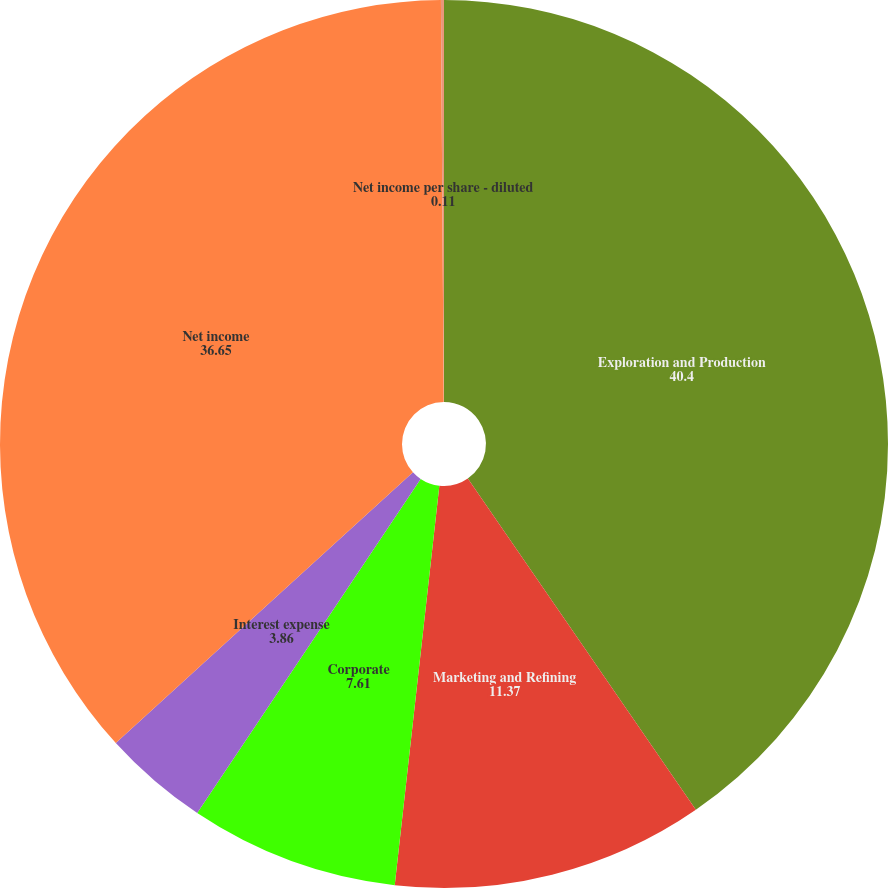<chart> <loc_0><loc_0><loc_500><loc_500><pie_chart><fcel>Exploration and Production<fcel>Marketing and Refining<fcel>Corporate<fcel>Interest expense<fcel>Net income<fcel>Net income per share - diluted<nl><fcel>40.4%<fcel>11.37%<fcel>7.61%<fcel>3.86%<fcel>36.65%<fcel>0.11%<nl></chart> 